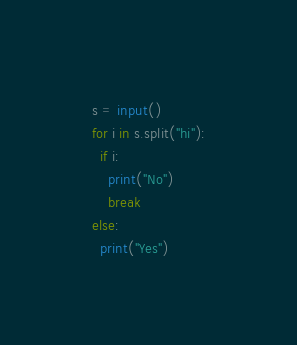Convert code to text. <code><loc_0><loc_0><loc_500><loc_500><_Python_>s = input()
for i in s.split("hi"):
  if i:
    print("No")
    break
else:
  print("Yes")
</code> 